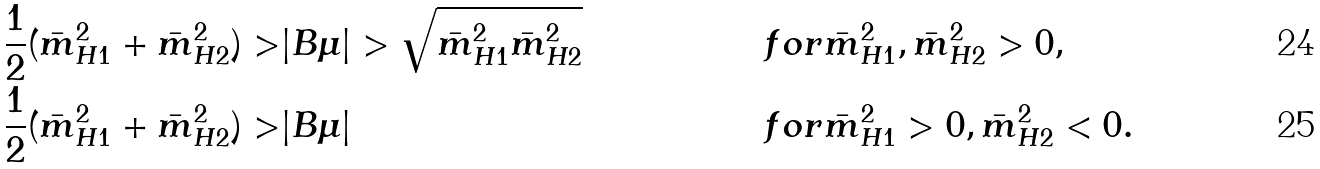<formula> <loc_0><loc_0><loc_500><loc_500>\frac { 1 } { 2 } ( \bar { m } ^ { 2 } _ { H 1 } + \bar { m } ^ { 2 } _ { H 2 } ) > & | B \mu | > \sqrt { \bar { m } ^ { 2 } _ { H 1 } \bar { m } ^ { 2 } _ { H 2 } } & f o r & \bar { m } ^ { 2 } _ { H 1 } , \bar { m } ^ { 2 } _ { H 2 } > 0 , \\ \frac { 1 } { 2 } ( \bar { m } ^ { 2 } _ { H 1 } + \bar { m } ^ { 2 } _ { H 2 } ) > & | B \mu | & f o r & \bar { m } ^ { 2 } _ { H 1 } > 0 , \bar { m } ^ { 2 } _ { H 2 } < 0 .</formula> 